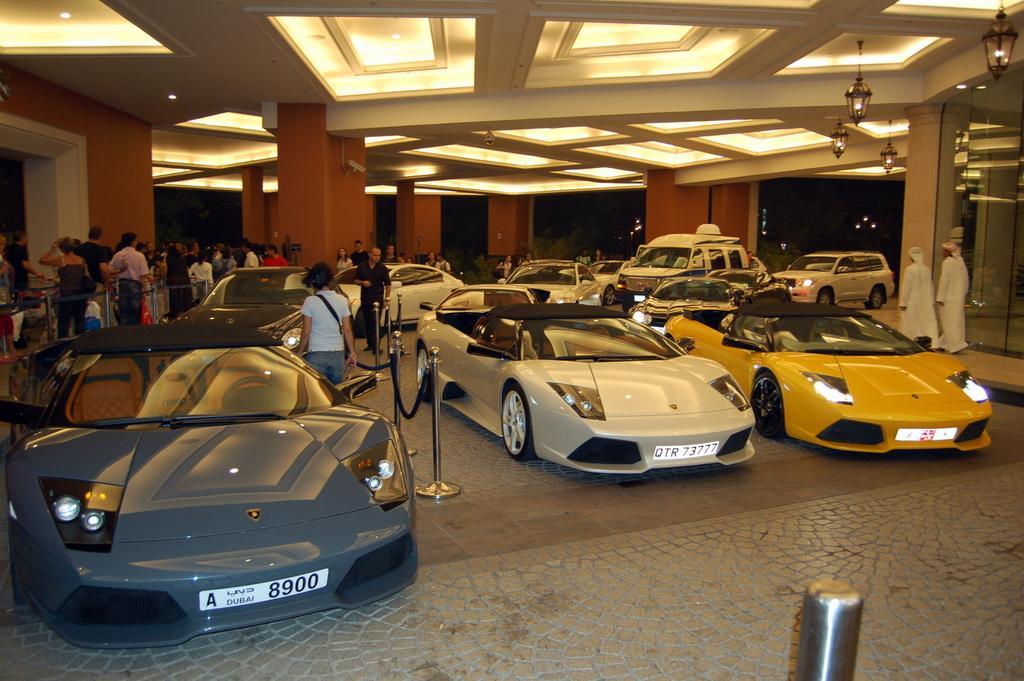Can you describe this image briefly? In the center of the image we can see cars, barricade stand and some persons are there. At the top of the image we can see roof, lights are there. In the middle of the image pillars, wall and glass are there. At the bottom of the image floor is there. 